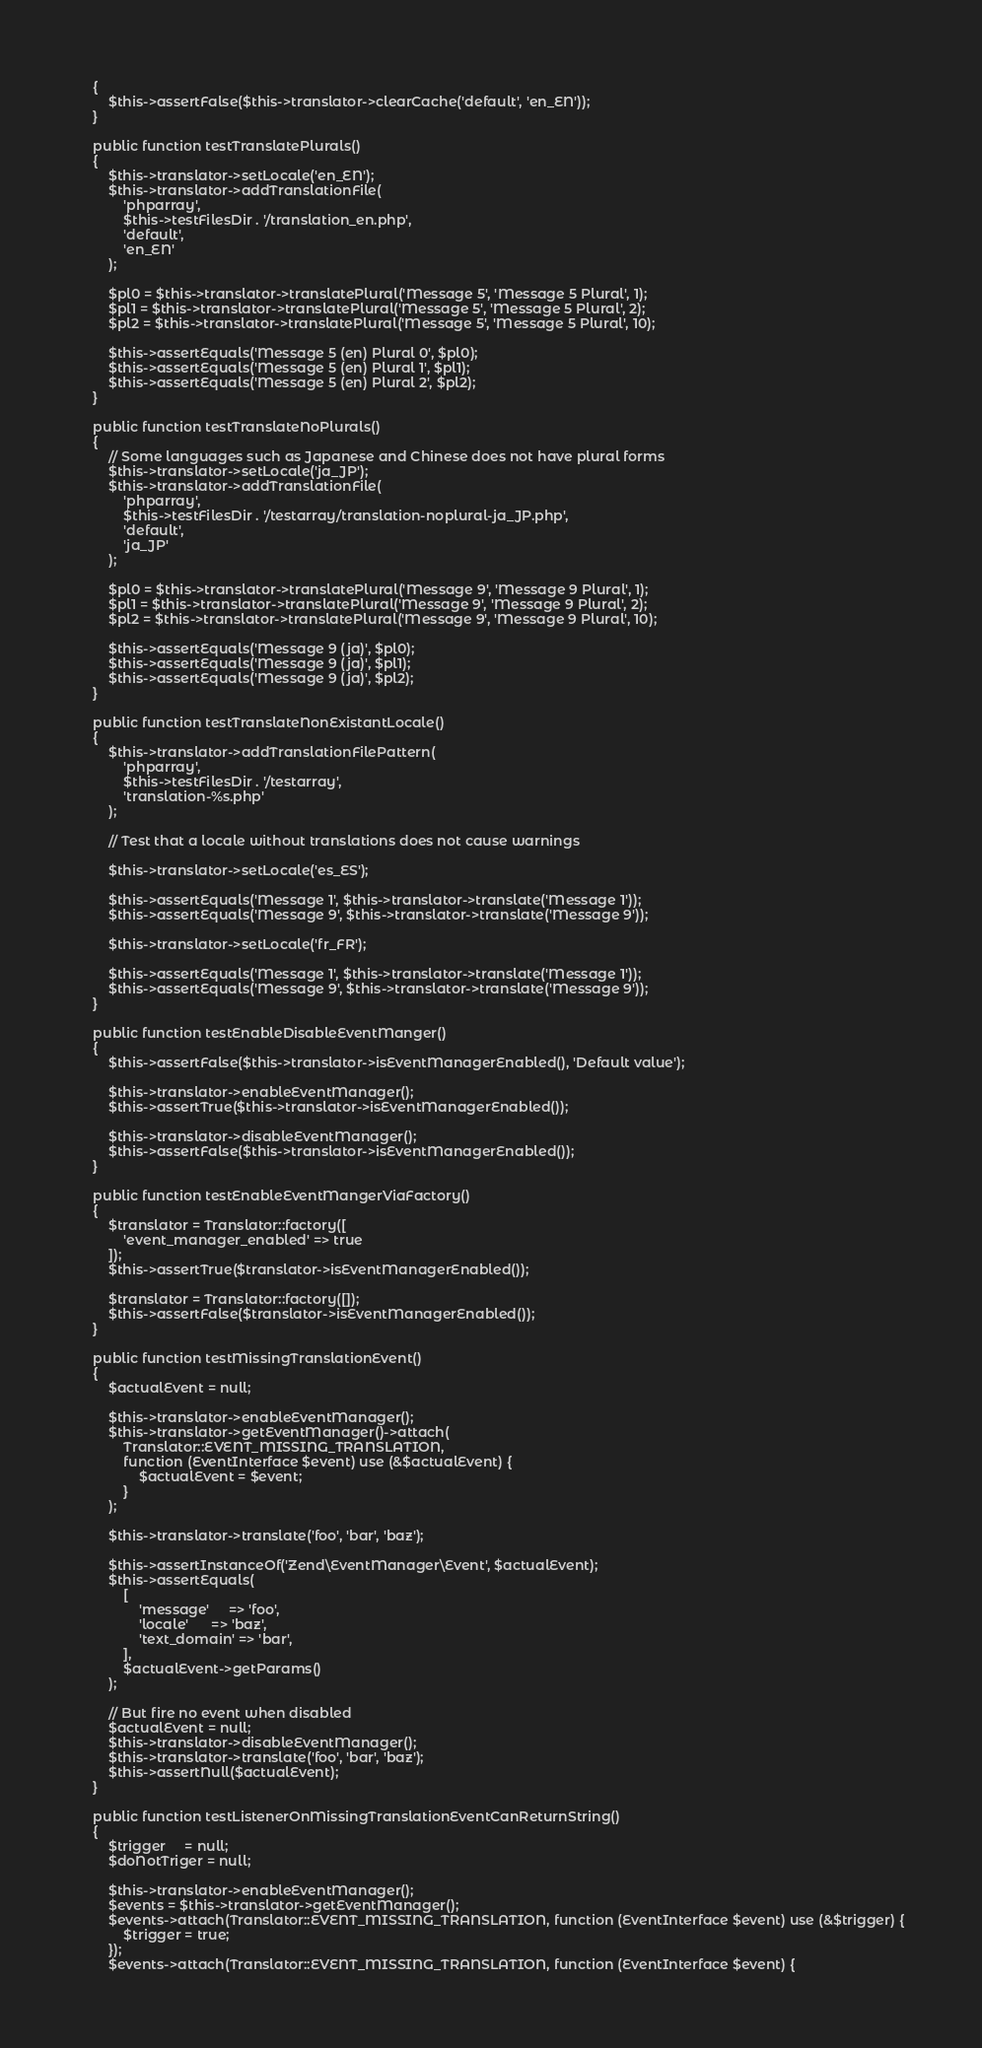Convert code to text. <code><loc_0><loc_0><loc_500><loc_500><_PHP_>    {
        $this->assertFalse($this->translator->clearCache('default', 'en_EN'));
    }

    public function testTranslatePlurals()
    {
        $this->translator->setLocale('en_EN');
        $this->translator->addTranslationFile(
            'phparray',
            $this->testFilesDir . '/translation_en.php',
            'default',
            'en_EN'
        );

        $pl0 = $this->translator->translatePlural('Message 5', 'Message 5 Plural', 1);
        $pl1 = $this->translator->translatePlural('Message 5', 'Message 5 Plural', 2);
        $pl2 = $this->translator->translatePlural('Message 5', 'Message 5 Plural', 10);

        $this->assertEquals('Message 5 (en) Plural 0', $pl0);
        $this->assertEquals('Message 5 (en) Plural 1', $pl1);
        $this->assertEquals('Message 5 (en) Plural 2', $pl2);
    }

    public function testTranslateNoPlurals()
    {
        // Some languages such as Japanese and Chinese does not have plural forms
        $this->translator->setLocale('ja_JP');
        $this->translator->addTranslationFile(
            'phparray',
            $this->testFilesDir . '/testarray/translation-noplural-ja_JP.php',
            'default',
            'ja_JP'
        );

        $pl0 = $this->translator->translatePlural('Message 9', 'Message 9 Plural', 1);
        $pl1 = $this->translator->translatePlural('Message 9', 'Message 9 Plural', 2);
        $pl2 = $this->translator->translatePlural('Message 9', 'Message 9 Plural', 10);

        $this->assertEquals('Message 9 (ja)', $pl0);
        $this->assertEquals('Message 9 (ja)', $pl1);
        $this->assertEquals('Message 9 (ja)', $pl2);
    }

    public function testTranslateNonExistantLocale()
    {
        $this->translator->addTranslationFilePattern(
            'phparray',
            $this->testFilesDir . '/testarray',
            'translation-%s.php'
        );

        // Test that a locale without translations does not cause warnings

        $this->translator->setLocale('es_ES');

        $this->assertEquals('Message 1', $this->translator->translate('Message 1'));
        $this->assertEquals('Message 9', $this->translator->translate('Message 9'));

        $this->translator->setLocale('fr_FR');

        $this->assertEquals('Message 1', $this->translator->translate('Message 1'));
        $this->assertEquals('Message 9', $this->translator->translate('Message 9'));
    }

    public function testEnableDisableEventManger()
    {
        $this->assertFalse($this->translator->isEventManagerEnabled(), 'Default value');

        $this->translator->enableEventManager();
        $this->assertTrue($this->translator->isEventManagerEnabled());

        $this->translator->disableEventManager();
        $this->assertFalse($this->translator->isEventManagerEnabled());
    }

    public function testEnableEventMangerViaFactory()
    {
        $translator = Translator::factory([
            'event_manager_enabled' => true
        ]);
        $this->assertTrue($translator->isEventManagerEnabled());

        $translator = Translator::factory([]);
        $this->assertFalse($translator->isEventManagerEnabled());
    }

    public function testMissingTranslationEvent()
    {
        $actualEvent = null;

        $this->translator->enableEventManager();
        $this->translator->getEventManager()->attach(
            Translator::EVENT_MISSING_TRANSLATION,
            function (EventInterface $event) use (&$actualEvent) {
                $actualEvent = $event;
            }
        );

        $this->translator->translate('foo', 'bar', 'baz');

        $this->assertInstanceOf('Zend\EventManager\Event', $actualEvent);
        $this->assertEquals(
            [
                'message'     => 'foo',
                'locale'      => 'baz',
                'text_domain' => 'bar',
            ],
            $actualEvent->getParams()
        );

        // But fire no event when disabled
        $actualEvent = null;
        $this->translator->disableEventManager();
        $this->translator->translate('foo', 'bar', 'baz');
        $this->assertNull($actualEvent);
    }

    public function testListenerOnMissingTranslationEventCanReturnString()
    {
        $trigger     = null;
        $doNotTriger = null;

        $this->translator->enableEventManager();
        $events = $this->translator->getEventManager();
        $events->attach(Translator::EVENT_MISSING_TRANSLATION, function (EventInterface $event) use (&$trigger) {
            $trigger = true;
        });
        $events->attach(Translator::EVENT_MISSING_TRANSLATION, function (EventInterface $event) {</code> 